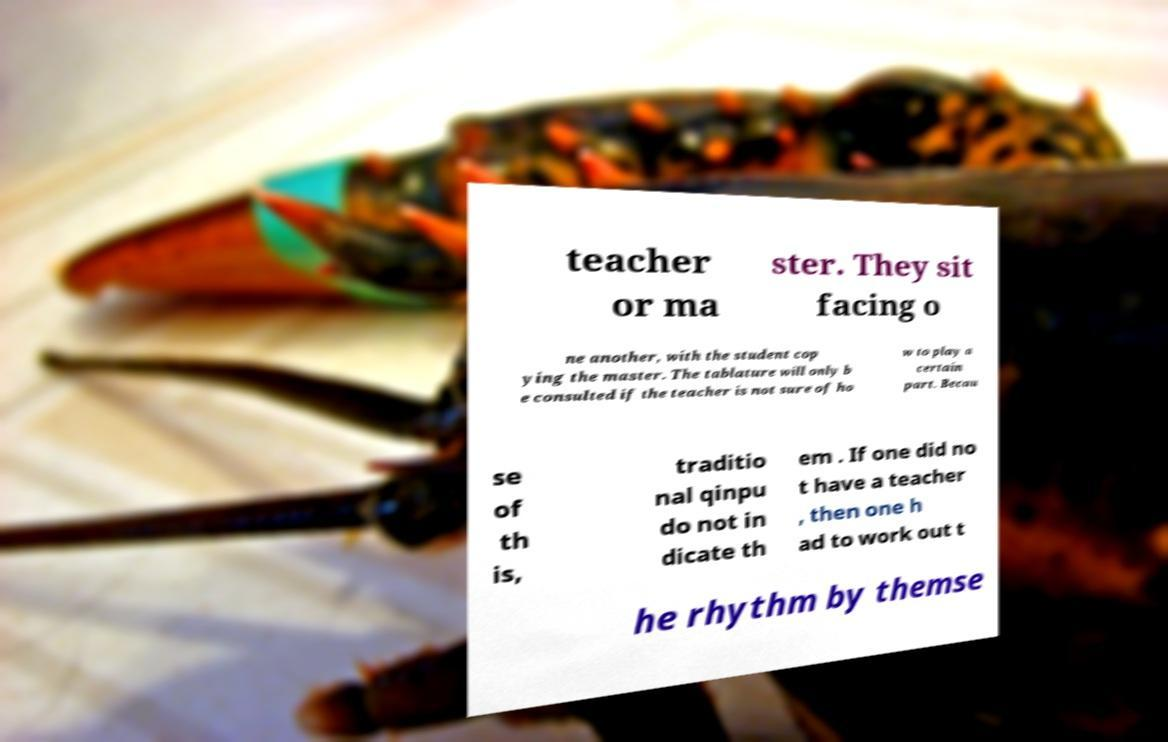Please identify and transcribe the text found in this image. teacher or ma ster. They sit facing o ne another, with the student cop ying the master. The tablature will only b e consulted if the teacher is not sure of ho w to play a certain part. Becau se of th is, traditio nal qinpu do not in dicate th em . If one did no t have a teacher , then one h ad to work out t he rhythm by themse 